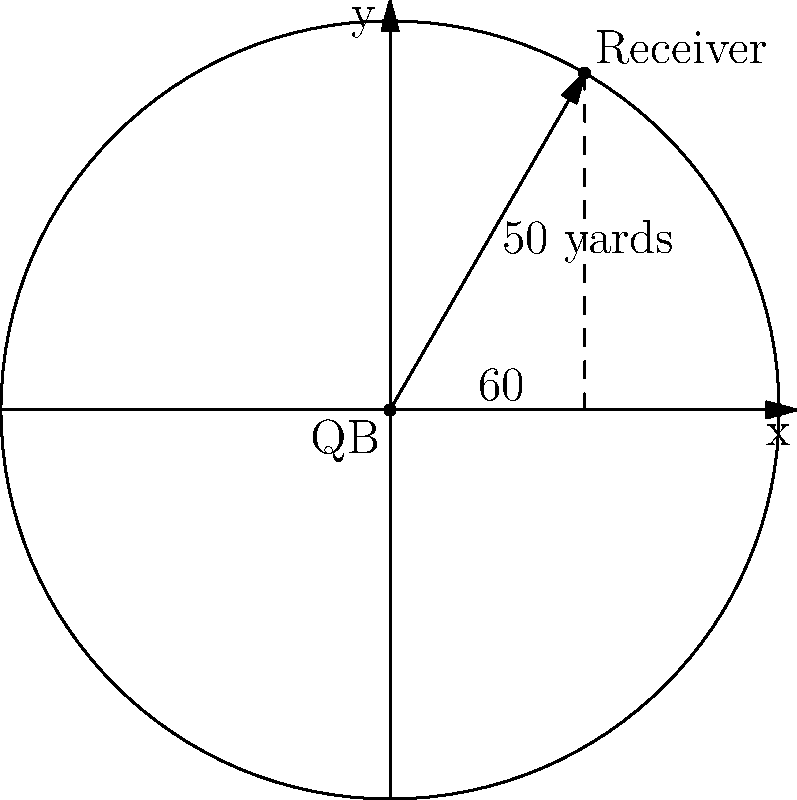In a crucial play, you as the quarterback throw a pass to your receiver. The pass travels 50 yards, and the receiver is at an angle of 60° from the positive x-axis (considering the QB's position as the origin). Using polar coordinates, how would you represent this pass? To represent the pass using polar coordinates, we need to consider two components:

1. The radial distance (r): This is the length of the pass, which is given as 50 yards.

2. The polar angle (θ): This is the angle from the positive x-axis, which is given as 60°.

In polar coordinates, a point is represented as (r, θ), where:
- r is the distance from the origin (in this case, the QB's position)
- θ is the angle from the positive x-axis (measured counterclockwise)

Therefore, the polar coordinate representation of the receiver's position relative to the QB is:

$$(50, 60°)$$

It's important to note that in polar coordinates:
- The first number represents the distance (in yards)
- The second number represents the angle (in degrees)

This representation succinctly describes both the direction and distance of the pass in a single coordinate pair.
Answer: $(50, 60°)$ 